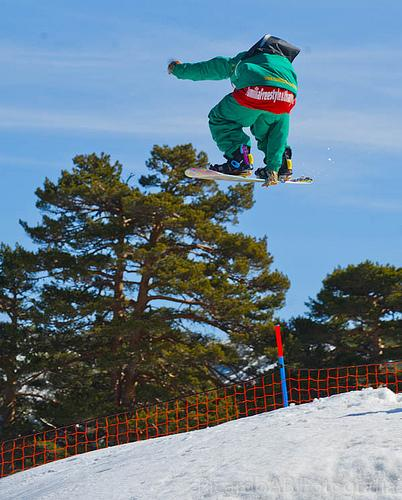Describe the pole in the image by mentioning its colors and location. The pole is red and blue, and it is situated near the orange netted fence. Mention the color of the bindings on the snowboard and any visible text on the snowboarder's shirt. The bindings are pink, blue, and yellow, and there is white text on the snowboarder's red shirt. Count the number of limbs of the snowboarder that are visible in the image. There are four limbs visible: two arms and two legs. Express the overall sentiment or emotion of the image based on the scene and environment. The scene evokes excitement and adventure, as it captures a snowboarder performing a daring jump amidst a snow-covered landscape. Identify the color and purpose of the fence in the image. The fence is orange and netted, likely serving as a safety barrier along the mountain. What is the state of the ground in the image? What kind of weather does it suggest? The ground is covered in white snow, suggesting a cold, winter weather. How many trees are visible in the image and which is the tallest? There are several trees visible, with the tallest tree located in the background. Can you describe the snowboarder's outfit in the image? The snowboarder is wearing a teal-green and red jacket, green winter pants, and colorful boots. Provide a brief overview of the image scene, including the subject and surroundings. The scene depicts a snowboarder in the air grabbing their snowboard, with an orange safety fence, trees, and a snow-covered slope in the background. What is the main action taking place in the image? A snowboarder is jumping off snow and grabbing their colorful snowboard in mid-air. 